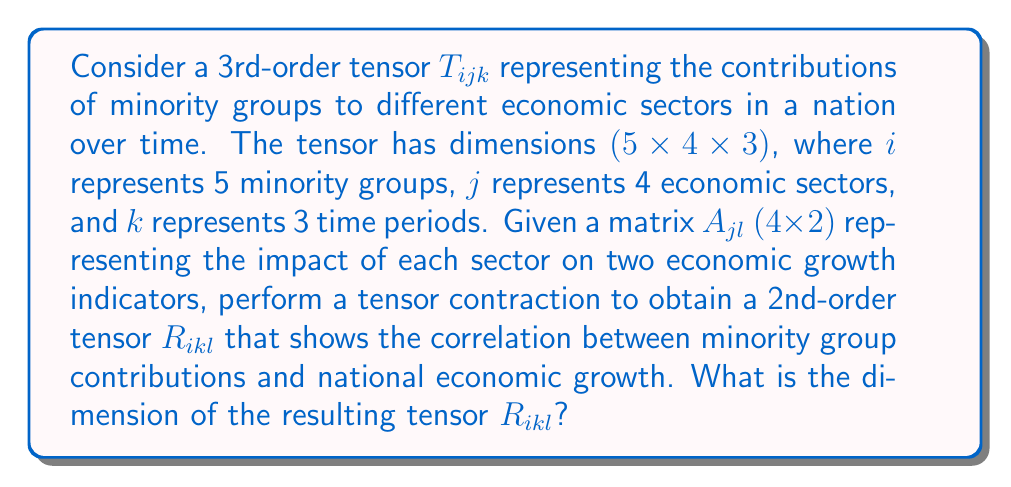Teach me how to tackle this problem. To solve this problem, we need to understand the concept of tensor contraction and apply it to the given scenario. Let's break it down step-by-step:

1) The initial tensor $T_{ijk}$ has dimensions $(5 \times 4 \times 3)$, where:
   - $i$ ranges from 1 to 5 (minority groups)
   - $j$ ranges from 1 to 4 (economic sectors)
   - $k$ ranges from 1 to 3 (time periods)

2) The matrix $A_{jl}$ has dimensions $(4 \times 2)$, where:
   - $j$ ranges from 1 to 4 (economic sectors)
   - $l$ ranges from 1 to 2 (economic growth indicators)

3) The tensor contraction operation will be performed over the $j$ index, which is common to both $T_{ijk}$ and $A_{jl}$. This can be represented mathematically as:

   $$R_{ikl} = \sum_{j=1}^{4} T_{ijk} A_{jl}$$

4) After the contraction, the resulting tensor $R_{ikl}$ will have the following properties:
   - $i$ will still range from 1 to 5 (minority groups)
   - $k$ will still range from 1 to 3 (time periods)
   - $l$ will range from 1 to 2 (economic growth indicators)

5) Therefore, the dimensions of $R_{ikl}$ will be:
   - 5 (from $i$) × 3 (from $k$) × 2 (from $l$)

Thus, the resulting tensor $R_{ikl}$ will have dimensions $(5 \times 3 \times 2)$.
Answer: $(5 \times 3 \times 2)$ 